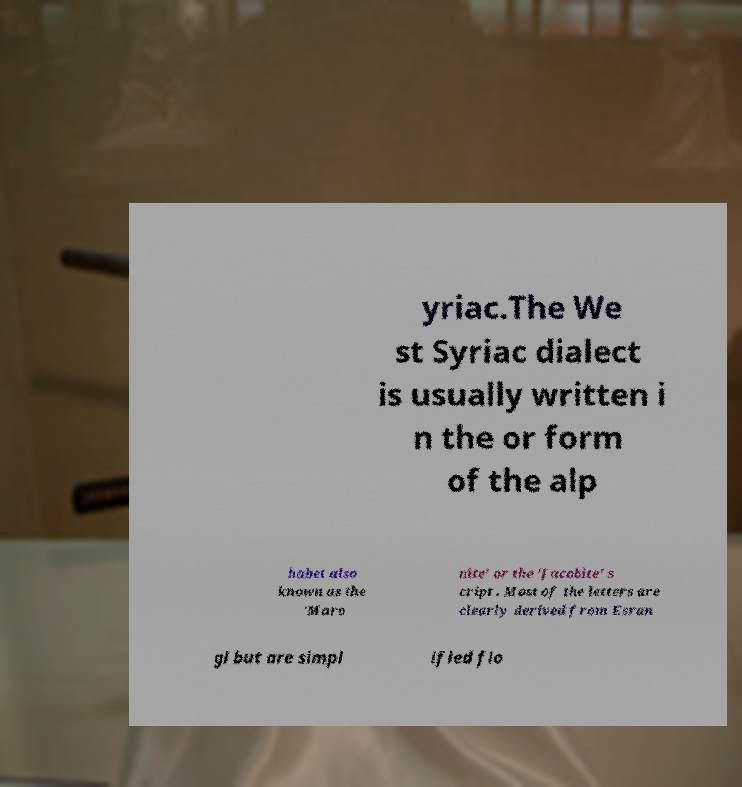Can you read and provide the text displayed in the image?This photo seems to have some interesting text. Can you extract and type it out for me? yriac.The We st Syriac dialect is usually written i n the or form of the alp habet also known as the 'Maro nite' or the 'Jacobite' s cript . Most of the letters are clearly derived from Esran gl but are simpl ified flo 